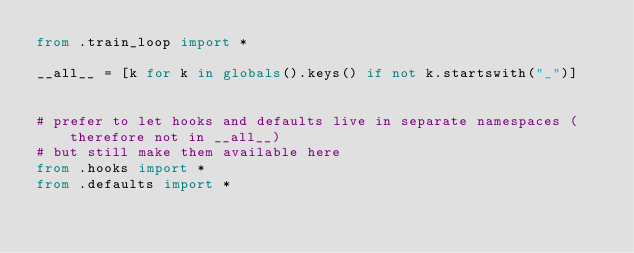Convert code to text. <code><loc_0><loc_0><loc_500><loc_500><_Python_>from .train_loop import *

__all__ = [k for k in globals().keys() if not k.startswith("_")]


# prefer to let hooks and defaults live in separate namespaces (therefore not in __all__)
# but still make them available here
from .hooks import *
from .defaults import *
</code> 